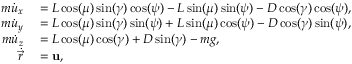Convert formula to latex. <formula><loc_0><loc_0><loc_500><loc_500>\begin{array} { r l } { m \ D o t { u } _ { x } } & = L \cos ( \mu ) \sin ( \gamma ) \cos ( \psi ) - L \sin ( \mu ) \sin ( \psi ) - D \cos ( \gamma ) \cos ( \psi ) , } \\ { m \ D o t { u } _ { y } } & = L \cos ( \mu ) \sin ( \gamma ) \sin ( \psi ) + L \sin ( \mu ) \cos ( \psi ) - D \cos ( \gamma ) \sin ( \psi ) , } \\ { m \ D o t { u } _ { z } } & = L \cos ( \mu ) \cos ( \gamma ) + D \sin ( \gamma ) - m g , } \\ { \ D o t { \vec { r } } } & = u , } \end{array}</formula> 